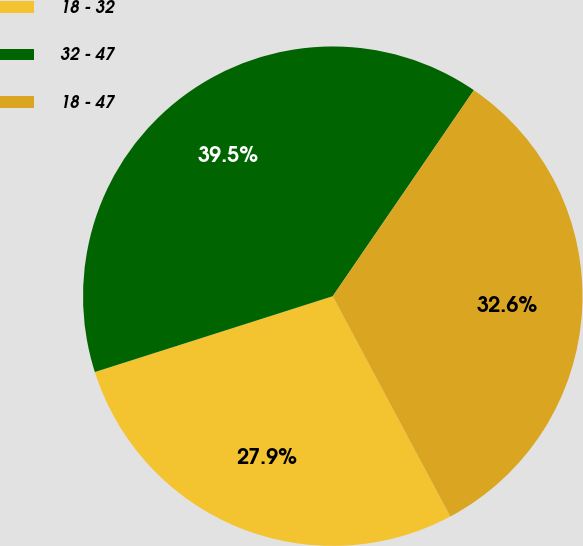<chart> <loc_0><loc_0><loc_500><loc_500><pie_chart><fcel>18 - 32<fcel>32 - 47<fcel>18 - 47<nl><fcel>27.89%<fcel>39.47%<fcel>32.64%<nl></chart> 